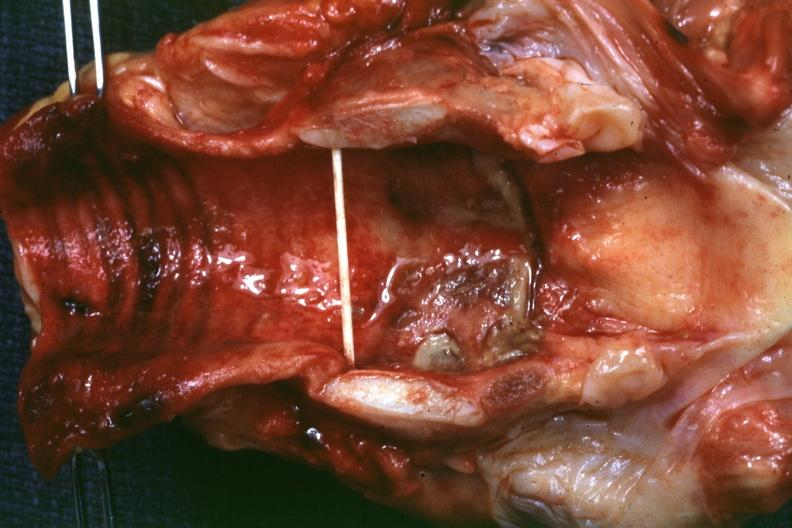s larynx present?
Answer the question using a single word or phrase. Yes 